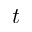Convert formula to latex. <formula><loc_0><loc_0><loc_500><loc_500>t</formula> 